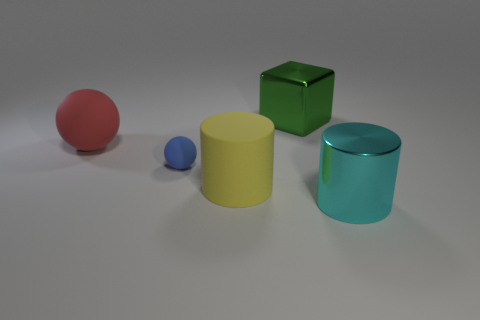The object left of the matte sphere that is in front of the big thing that is left of the yellow matte object is made of what material? The object to the left of the matte red sphere, which is positioned in front of the larger cyan cylinder to the left of the yellow matte cylinder, appears to be a small, matte blue sphere. Given the context and the visual characteristics of the object, it is likely a representation of a solid material, such as plastic or painted wood, rather than rubber, which would typically exhibit more shine or reflections. 